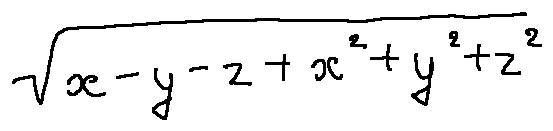<formula> <loc_0><loc_0><loc_500><loc_500>\sqrt { x - y - z + x ^ { 2 } + y ^ { 2 } + z ^ { 2 } }</formula> 